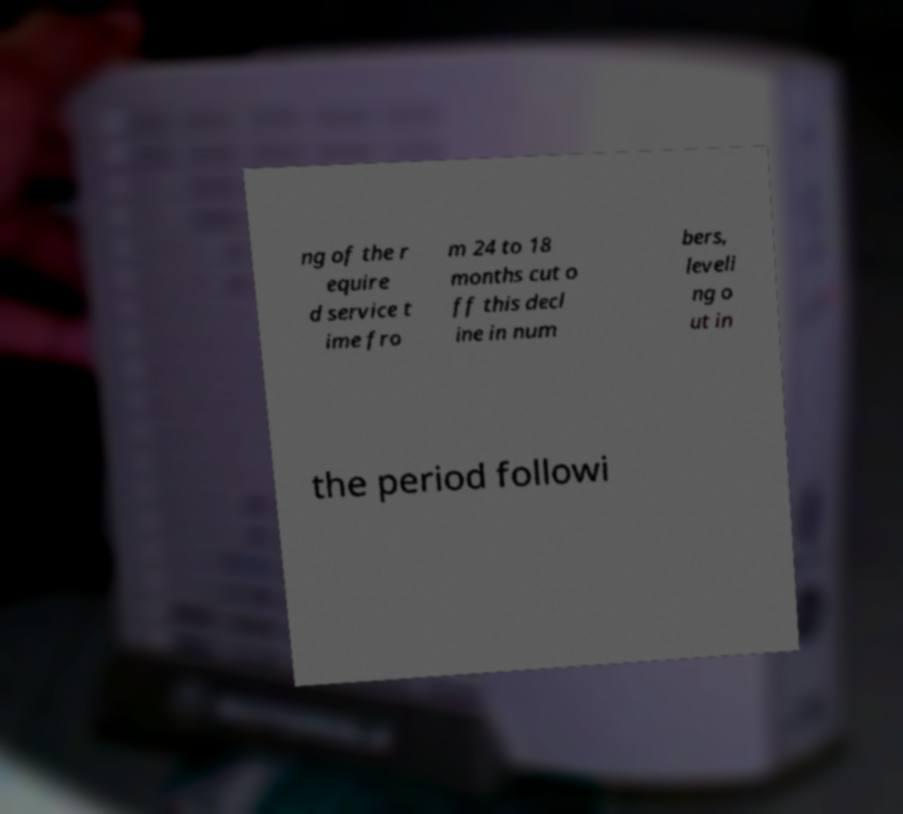Could you assist in decoding the text presented in this image and type it out clearly? ng of the r equire d service t ime fro m 24 to 18 months cut o ff this decl ine in num bers, leveli ng o ut in the period followi 